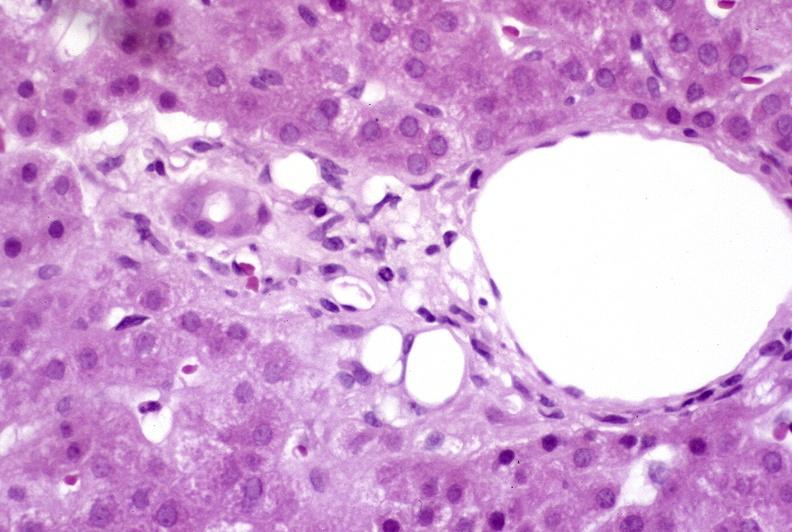s liver present?
Answer the question using a single word or phrase. Yes 